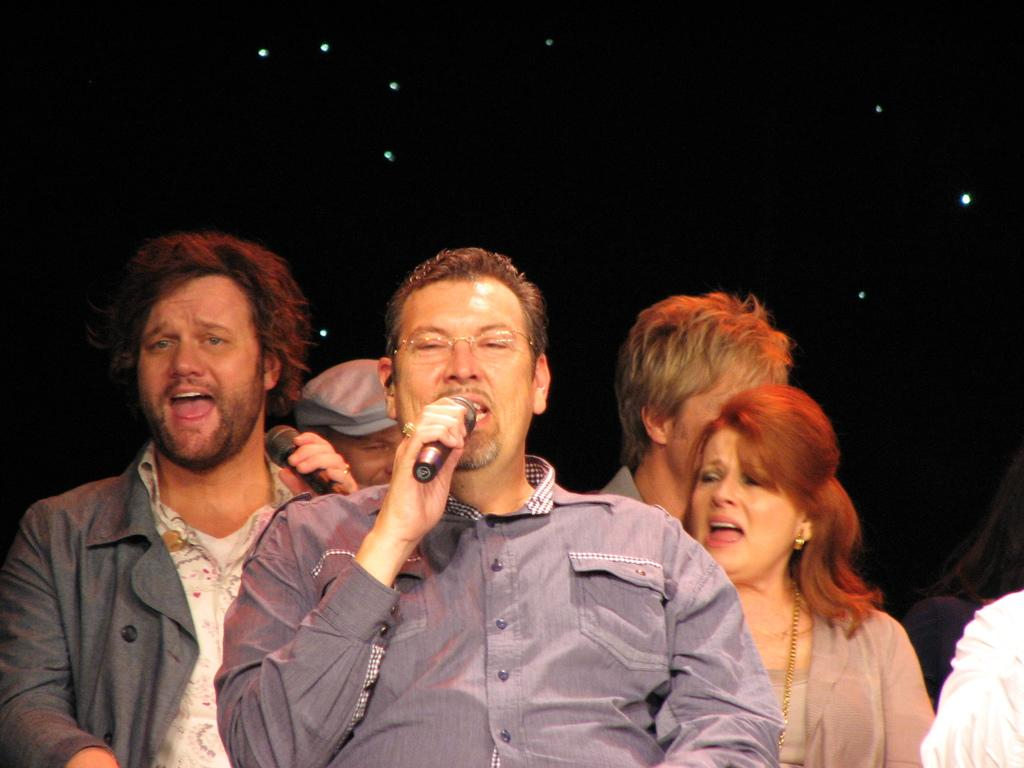How many people are in the image? There are persons in the image. What are two of the persons doing in the image? Two of the persons are talking on a microphone. Can you describe any specific features of one of the persons? One of the persons has spectacles. What is the wealth of the park in the image? There is no park present in the image, so it is not possible to determine its wealth. 